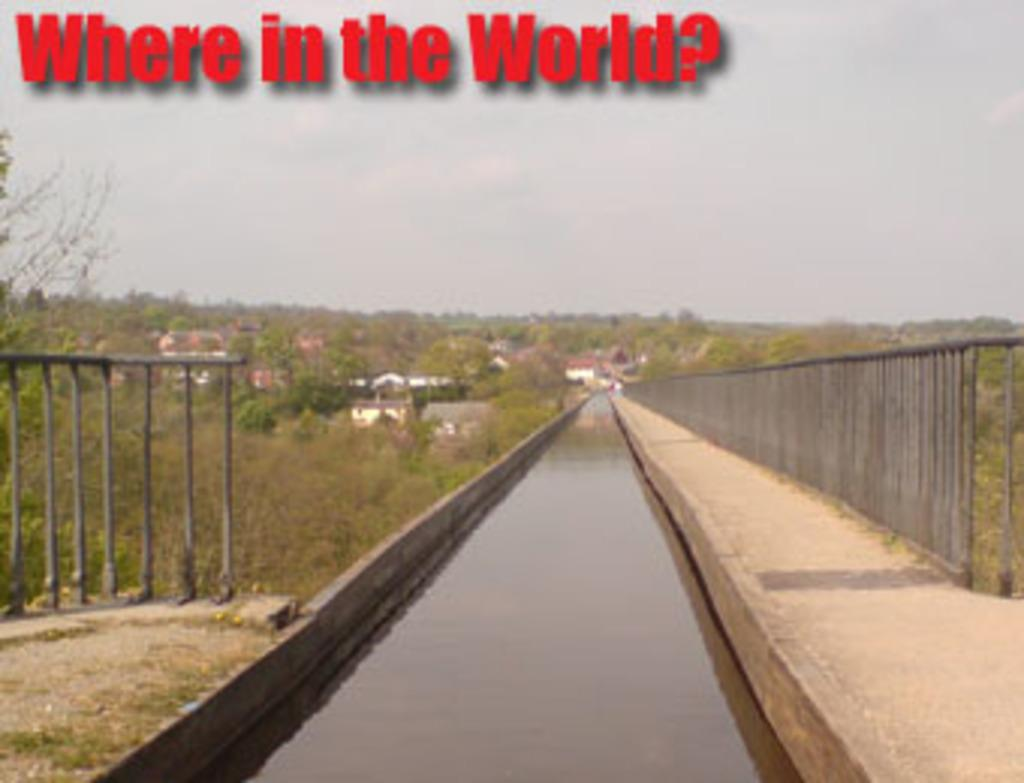What type of structures can be seen in the image? There are fences, a path, water, trees, buildings, grass, and text visible in the image. What can be found in the background of the image? The sky is visible in the background of the image. What type of vegetation is present in the image? Trees and grass are present in the image. How many different elements can be identified in the image? There are at least eight different elements in the image: fences, a path, water, trees, buildings, grass, text, and the sky. What type of beef is being served in the image? There is no beef present in the image. Can you see a pocket in the image? There is no pocket visible in the image. 